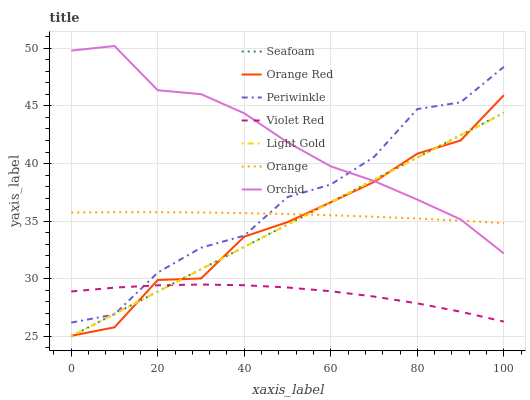Does Violet Red have the minimum area under the curve?
Answer yes or no. Yes. Does Orchid have the maximum area under the curve?
Answer yes or no. Yes. Does Seafoam have the minimum area under the curve?
Answer yes or no. No. Does Seafoam have the maximum area under the curve?
Answer yes or no. No. Is Seafoam the smoothest?
Answer yes or no. Yes. Is Periwinkle the roughest?
Answer yes or no. Yes. Is Periwinkle the smoothest?
Answer yes or no. No. Is Seafoam the roughest?
Answer yes or no. No. Does Seafoam have the lowest value?
Answer yes or no. Yes. Does Periwinkle have the lowest value?
Answer yes or no. No. Does Orchid have the highest value?
Answer yes or no. Yes. Does Seafoam have the highest value?
Answer yes or no. No. Is Orange Red less than Periwinkle?
Answer yes or no. Yes. Is Orange greater than Violet Red?
Answer yes or no. Yes. Does Violet Red intersect Seafoam?
Answer yes or no. Yes. Is Violet Red less than Seafoam?
Answer yes or no. No. Is Violet Red greater than Seafoam?
Answer yes or no. No. Does Orange Red intersect Periwinkle?
Answer yes or no. No. 